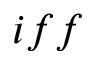<formula> <loc_0><loc_0><loc_500><loc_500>i f f</formula> 